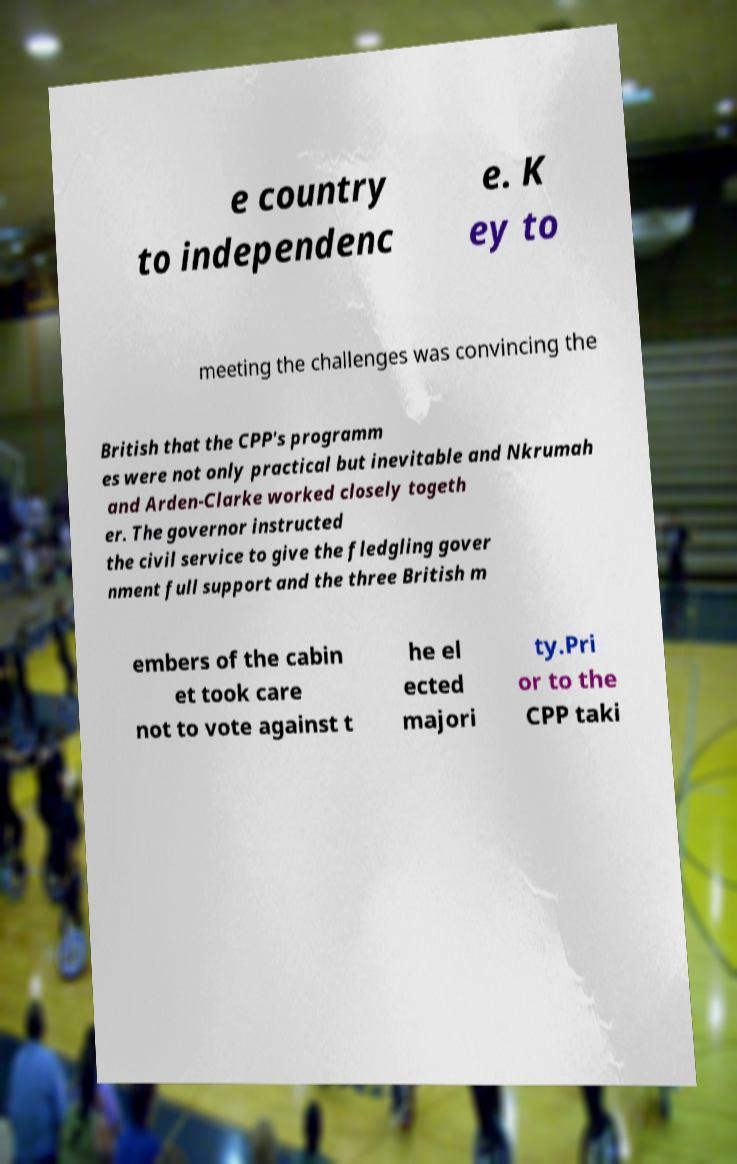Can you accurately transcribe the text from the provided image for me? e country to independenc e. K ey to meeting the challenges was convincing the British that the CPP's programm es were not only practical but inevitable and Nkrumah and Arden-Clarke worked closely togeth er. The governor instructed the civil service to give the fledgling gover nment full support and the three British m embers of the cabin et took care not to vote against t he el ected majori ty.Pri or to the CPP taki 